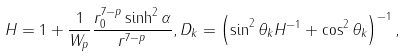<formula> <loc_0><loc_0><loc_500><loc_500>H = 1 + \frac { 1 } { W _ { p } } \frac { r _ { 0 } ^ { 7 - p } \sinh ^ { 2 } \alpha } { r ^ { 7 - p } } , D _ { k } = \left ( \sin ^ { 2 } \theta _ { k } H ^ { - 1 } + \cos ^ { 2 } \theta _ { k } \right ) ^ { - 1 } ,</formula> 